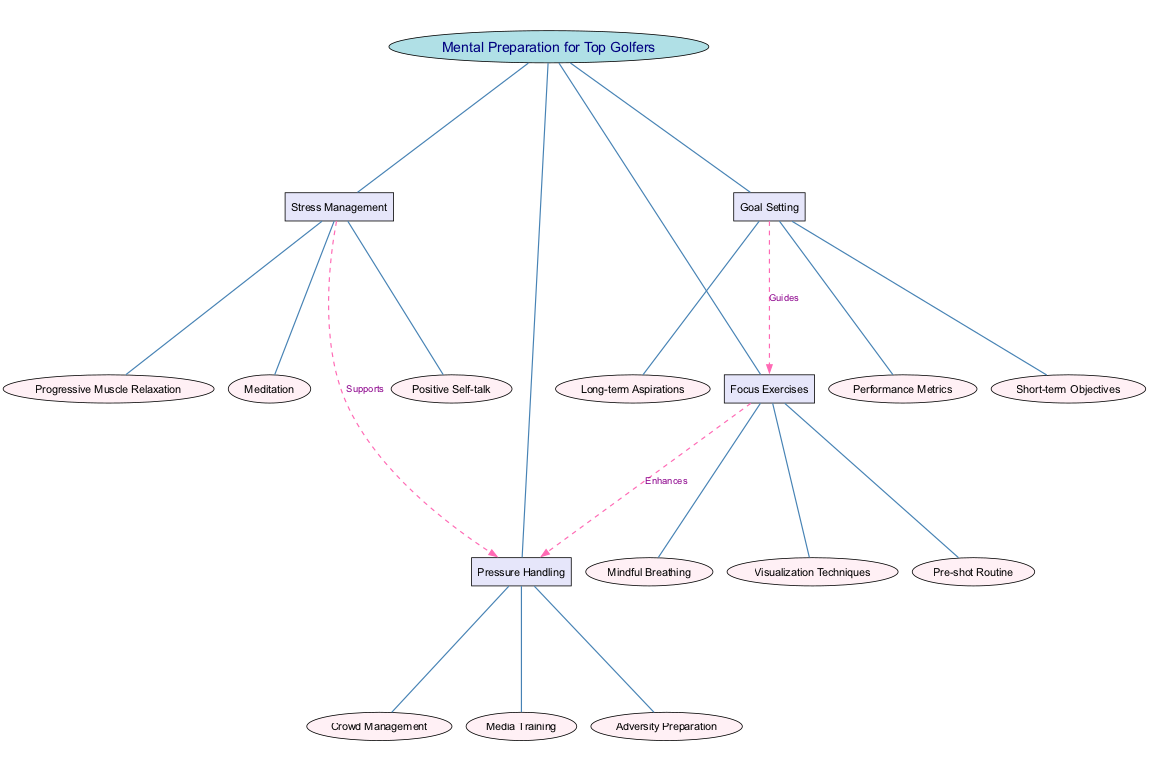What is the central topic of the diagram? The central topic node is labeled "Mental Preparation for Top Golfers," which serves as the main focus of the entire diagram.
Answer: Mental Preparation for Top Golfers How many main branches are there in the diagram? The diagram contains four main branches: Focus Exercises, Stress Management, Goal Setting, and Pressure Handling, thus totaling four branches.
Answer: 4 What are the sub-branches of Stress Management? The Stress Management branch has three sub-branches: Positive Self-talk, Progressive Muscle Relaxation, and Meditation, which can be directly observed under the Stress Management node.
Answer: Positive Self-talk, Progressive Muscle Relaxation, Meditation Which branch enhances Pressure Handling? The edge labeled "Enhances" connects the Focus Exercises branch to the Pressure Handling branch, indicating that Focus Exercises enhance Pressure Handling.
Answer: Focus Exercises How does Goal Setting relate to Focus Exercises? The diagram shows a directed connection labeled "Guides" from the Goal Setting branch to the Focus Exercises branch, signifying that Goal Setting serves to guide Focus Exercises.
Answer: Guides What color represents the nodes for sub-branches in the diagram? The nodes for sub-branches are filled with the color #FFF0F5, which can be identified by examining the attributes of these specific nodes in the diagram.
Answer: #FFF0F5 Which method supports Pressure Handling? The Stress Management branch has a connection labeled "Supports" that goes to Pressure Handling, demonstrating that it supports this area of mental preparation.
Answer: Stress Management What is the number of edges connecting branches in the diagram? There are a total of four edges visible: three for connecting branches to the central topic and one for each of the three connections among branches, leading to a total of six edges.
Answer: 6 What is the relationship between Focus Exercises and Pressure Handling? There is a directed edge labeled "Enhances" from Focus Exercises to Pressure Handling, establishing that Focus Exercises specifically enhance the ability to handle pressure.
Answer: Enhances 